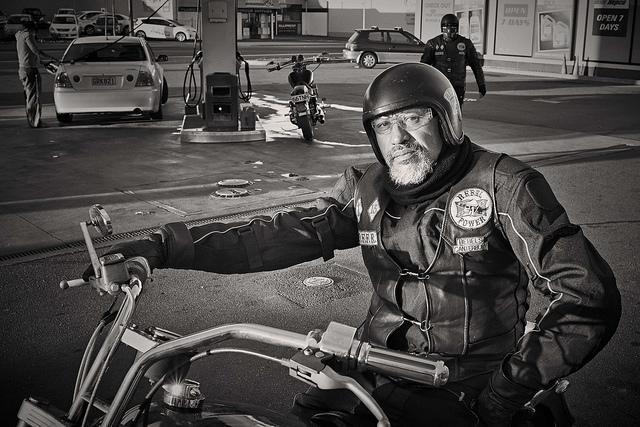How many mirrors are on the motorcycle?
Give a very brief answer. 1. How many people are visible?
Give a very brief answer. 3. How many cars are in the photo?
Give a very brief answer. 2. How many motorcycles are there?
Give a very brief answer. 2. 